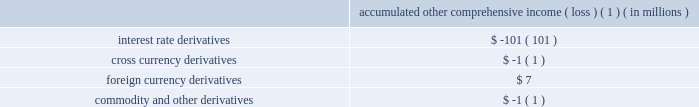The aes corporation notes to consolidated financial statements 2014 ( continued ) december 31 , 2011 , 2010 , and 2009 the table below sets forth the pre-tax accumulated other comprehensive income ( loss ) expected to be recognized as an increase ( decrease ) to income from continuing operations before income taxes over the next twelve months as of december 31 , 2011 for the following types of derivative instruments : accumulated other comprehensive income ( loss ) ( 1 ) ( in millions ) .
( 1 ) excludes a loss of $ 94 million expected to be recognized as part of the sale of cartagena , which closed on february 9 , 2012 , and is further discussed in note 23 2014acquisitions and dispositions .
The balance in accumulated other comprehensive loss related to derivative transactions will be reclassified into earnings as interest expense is recognized for interest rate hedges and cross currency swaps ( except for the amount reclassified to foreign currency transaction gains and losses to offset the remeasurement of the foreign currency-denominated debt being hedged by the cross currency swaps ) , as depreciation is recognized for interest rate hedges during construction , as foreign currency transaction gains and losses are recognized for hedges of foreign currency exposure , and as electricity sales and fuel purchases are recognized for hedges of forecasted electricity and fuel transactions .
These balances are included in the consolidated statements of cash flows as operating and/or investing activities based on the nature of the underlying transaction .
For the years ended december 31 , 2011 , 2010 and 2009 , pre-tax gains ( losses ) of $ 0 million , $ ( 1 ) million , and $ 0 million net of noncontrolling interests , respectively , were reclassified into earnings as a result of the discontinuance of a cash flow hedge because it was probable that the forecasted transaction would not occur by the end of the originally specified time period ( as documented at the inception of the hedging relationship ) or within an additional two-month time period thereafter. .
What is total aoci ( in millions ) for 2011? 
Computations: (((7 + -1) + -1) + -101)
Answer: -96.0. 